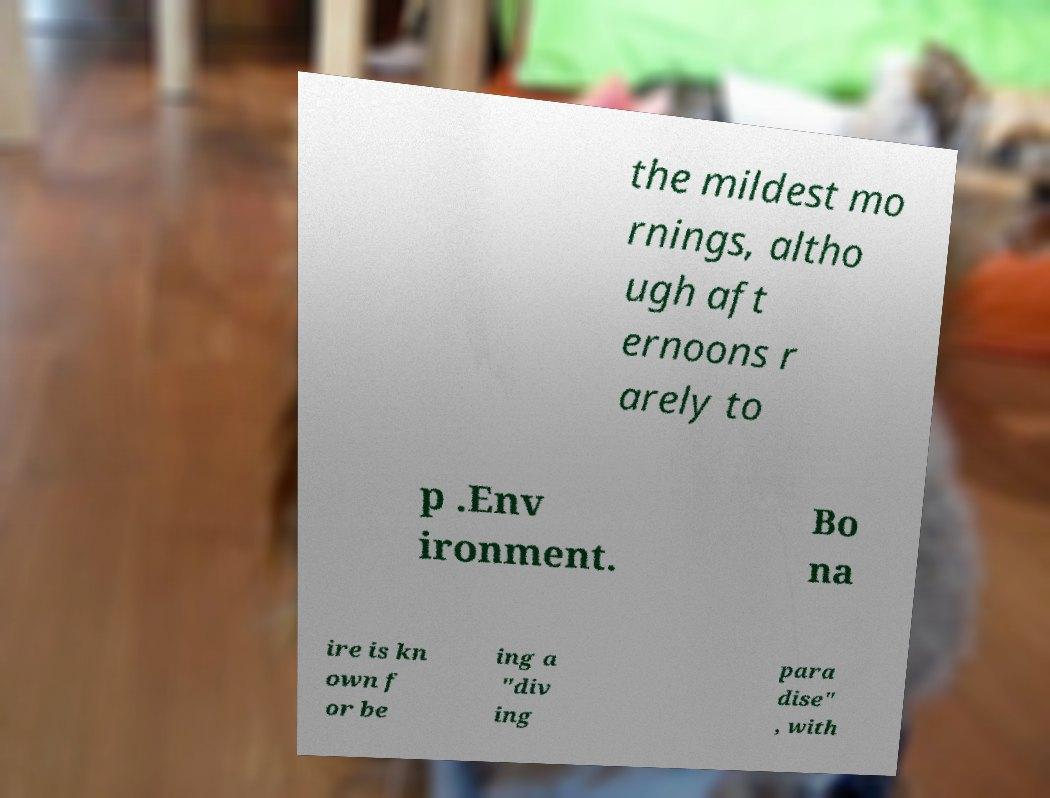Please identify and transcribe the text found in this image. the mildest mo rnings, altho ugh aft ernoons r arely to p .Env ironment. Bo na ire is kn own f or be ing a "div ing para dise" , with 